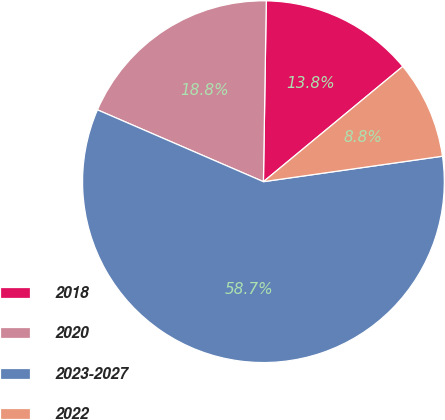Convert chart to OTSL. <chart><loc_0><loc_0><loc_500><loc_500><pie_chart><fcel>2018<fcel>2020<fcel>2023-2027<fcel>2022<nl><fcel>13.75%<fcel>18.75%<fcel>58.75%<fcel>8.75%<nl></chart> 